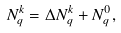<formula> <loc_0><loc_0><loc_500><loc_500>N _ { q } ^ { k } = \Delta N _ { q } ^ { k } + N _ { q } ^ { 0 } ,</formula> 